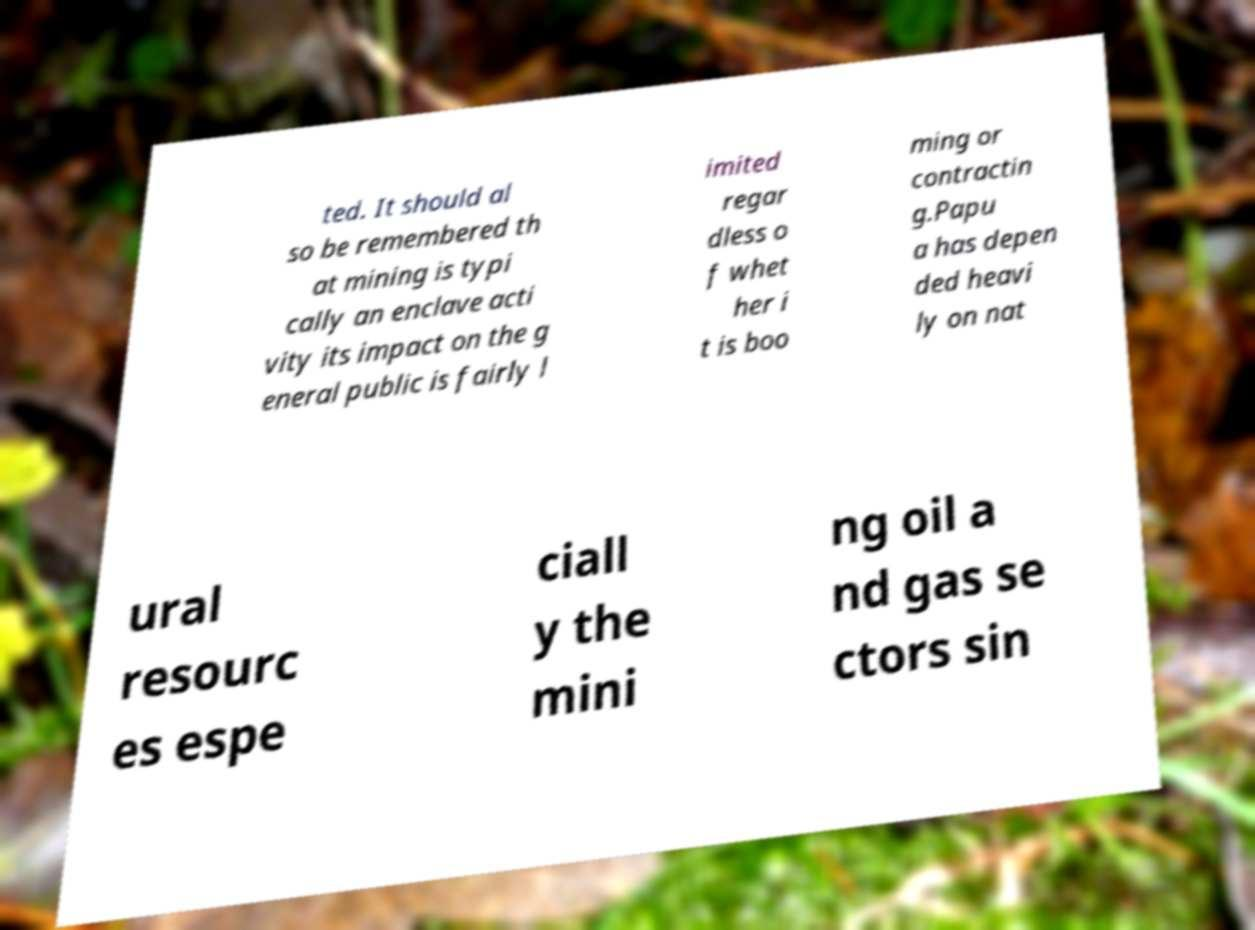There's text embedded in this image that I need extracted. Can you transcribe it verbatim? ted. It should al so be remembered th at mining is typi cally an enclave acti vity its impact on the g eneral public is fairly l imited regar dless o f whet her i t is boo ming or contractin g.Papu a has depen ded heavi ly on nat ural resourc es espe ciall y the mini ng oil a nd gas se ctors sin 